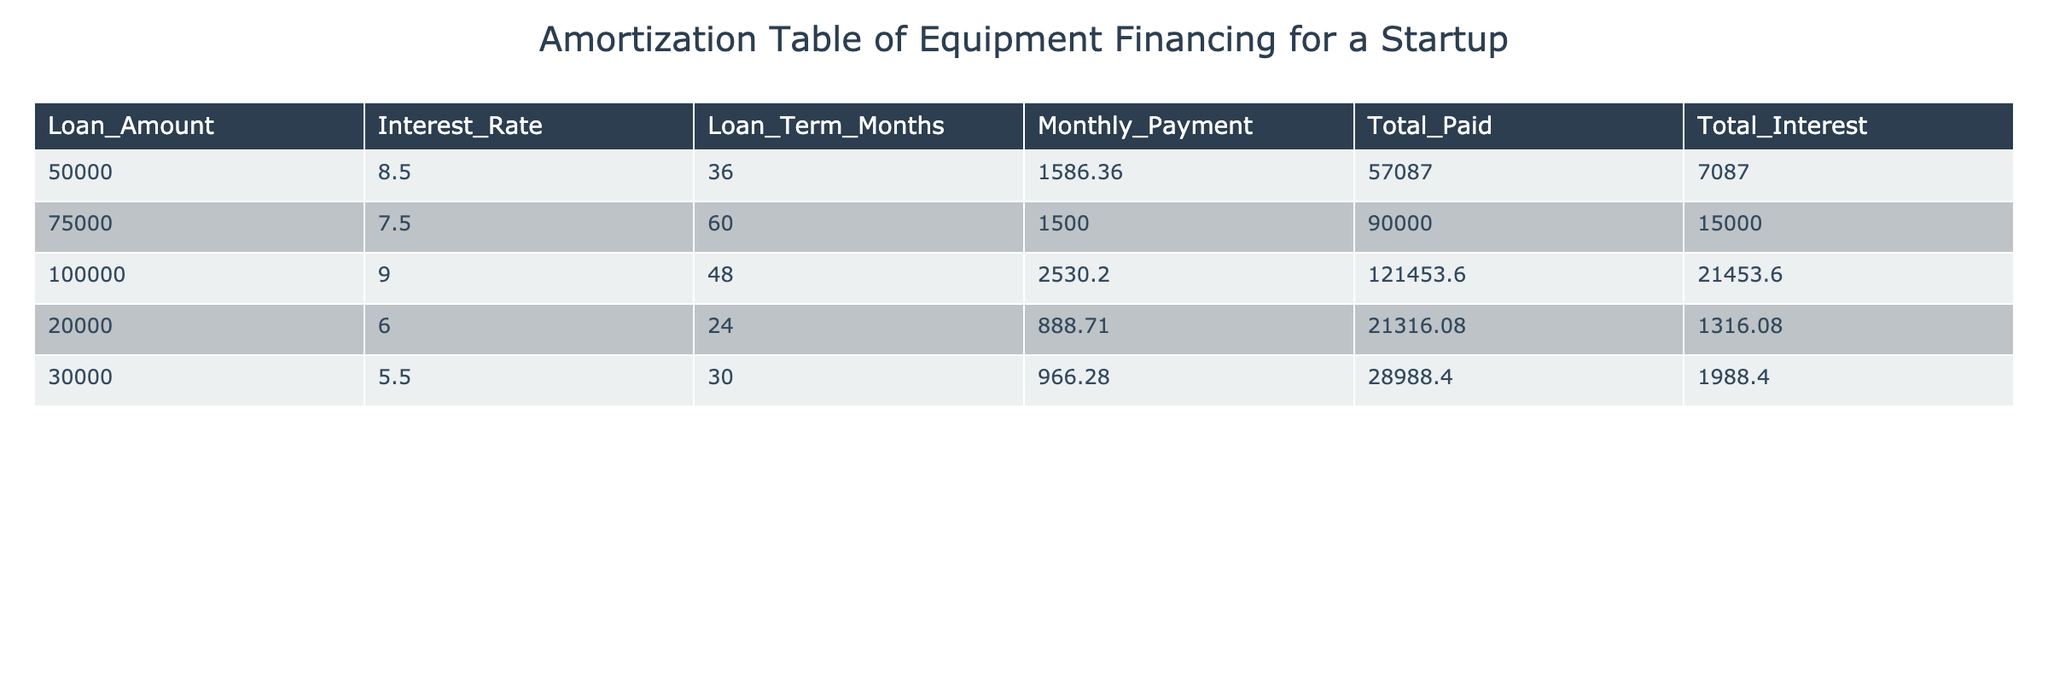What is the monthly payment for the loan amount of 75,000? The table shows the loan amount of 75,000 has a corresponding monthly payment value of 1500. Therefore, the answer can be retrieved directly from the table.
Answer: 1500 Which loan has the highest total interest paid? By inspecting the "Total Interest" column, the loan with the highest amount is 21453.60, corresponding to the loan of 100,000. This indicates that this loan has the highest interest paid.
Answer: 100,000 What is the total amount paid for the equipment financing of 20,000? Looking at the total paid column for the loan amount of 20,000, the value is 21316.08, which shows the total amount paid includes the original loan and interest.
Answer: 21316.08 How much interest is paid for the loan amount of 30,000? The interest paid for the loan amount of 30,000 is directly given in the table as 1988.40. This can be confirmed from the "Total Interest" column.
Answer: 1988.40 Is the monthly payment for the loan amount of 50,000 greater than 1,600? The monthly payment for a loan amount of 50,000 is 1586.36 as shown in the table. Since 1586.36 is less than 1,600, the answer is no.
Answer: No What is the average monthly payment for all loans listed in the table? To find the average monthly payment, first, add all monthly payments: (1586.36 + 1500 + 2530.20 + 888.71 + 966.28) = 6571.55. Then, divide by the number of loans (5). Thus, 6571.55 / 5 = 1314.31.
Answer: 1314.31 Which loan has the lowest total paid amount? By scanning the "Total Paid" column, the loan amount of 20,000 has the lowest total paid amount of 21316.08, suggesting it is the lowest compared to others.
Answer: 20,000 Is the interest rate for the loan amount of 50,000 higher than that for the loan amount of 30,000? The interest rate for the loan of 50,000 is 8.5% and for the loan of 30,000 is 5.5%. Since 8.5% is indeed higher than 5.5%, the answer is yes.
Answer: Yes What is the total interest amount for all loans combined? Total the "Total Interest" column values: (7087 + 15000 + 21453.60 + 1316.08 + 1988.40) = 48844.08. Thus, summing these gives the total interest across all loans.
Answer: 48844.08 